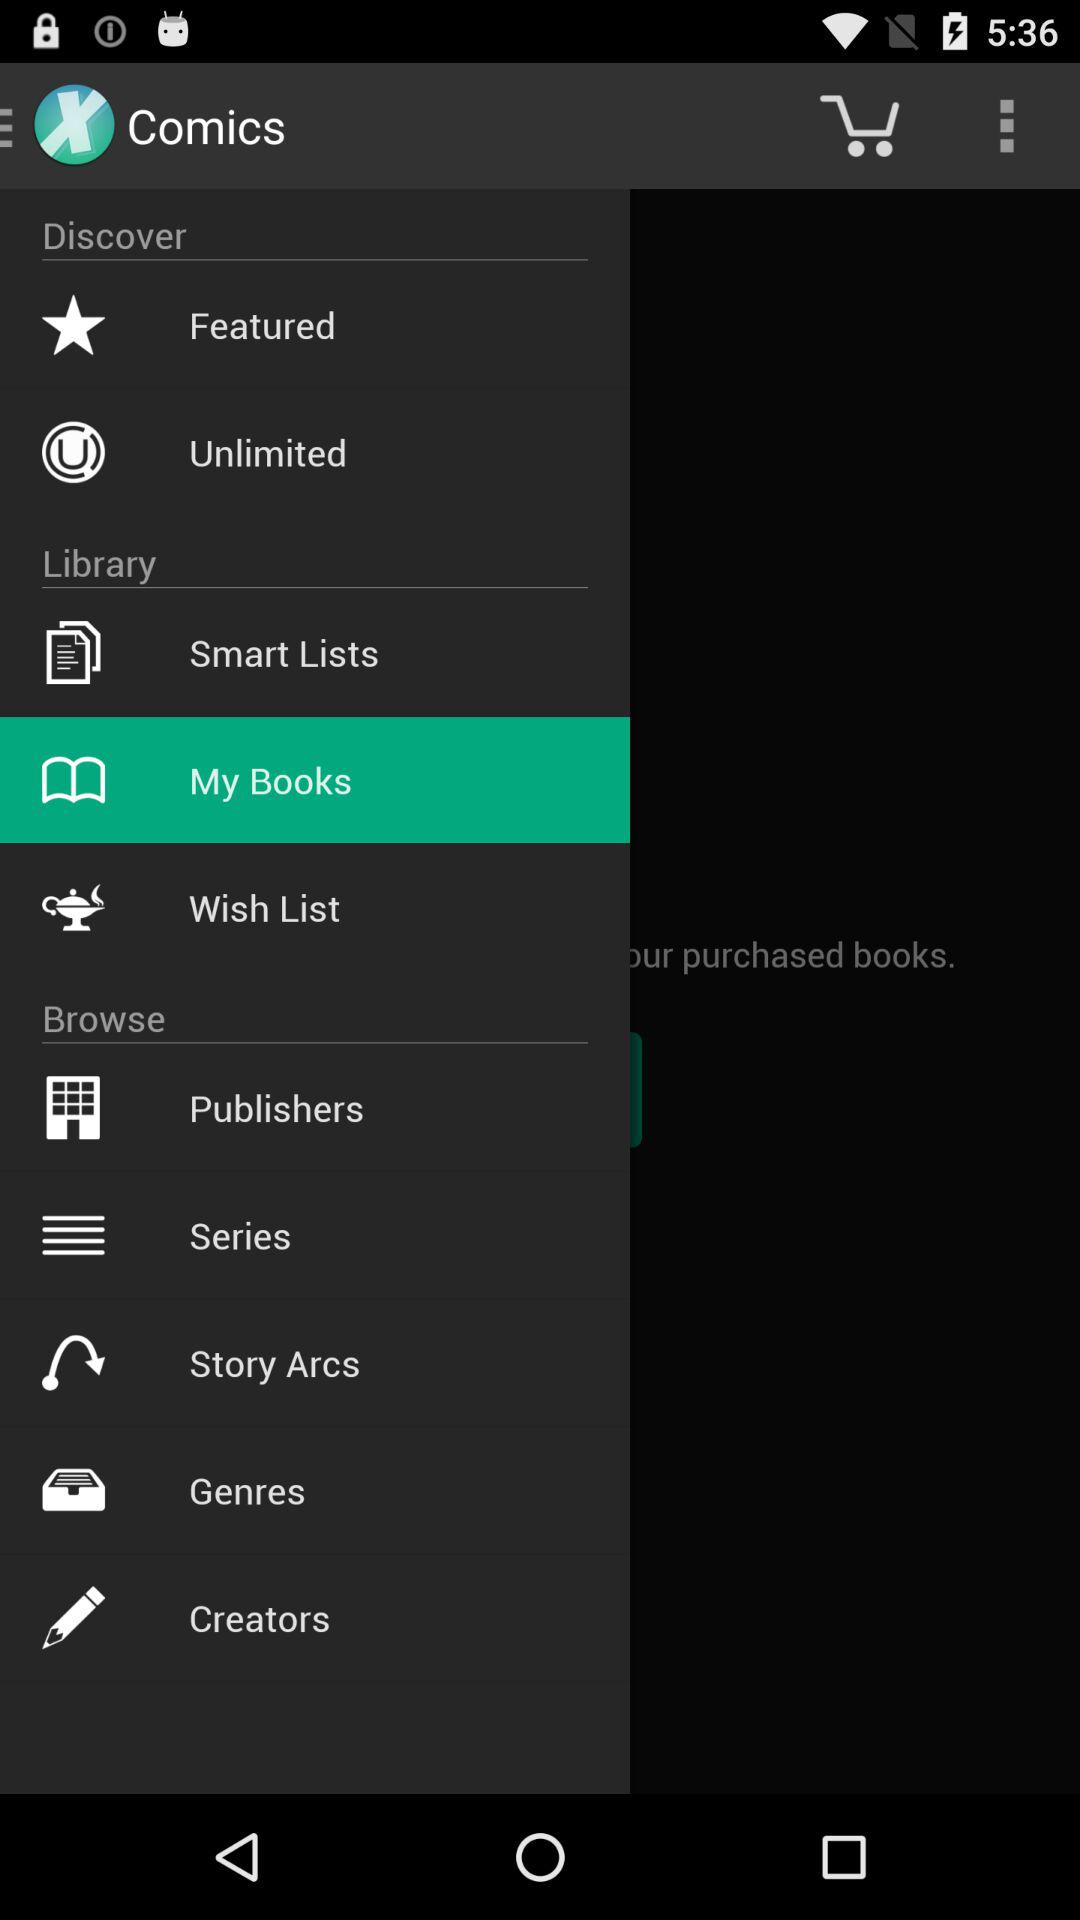What is the name of the application? The name of the application is "Comics". 